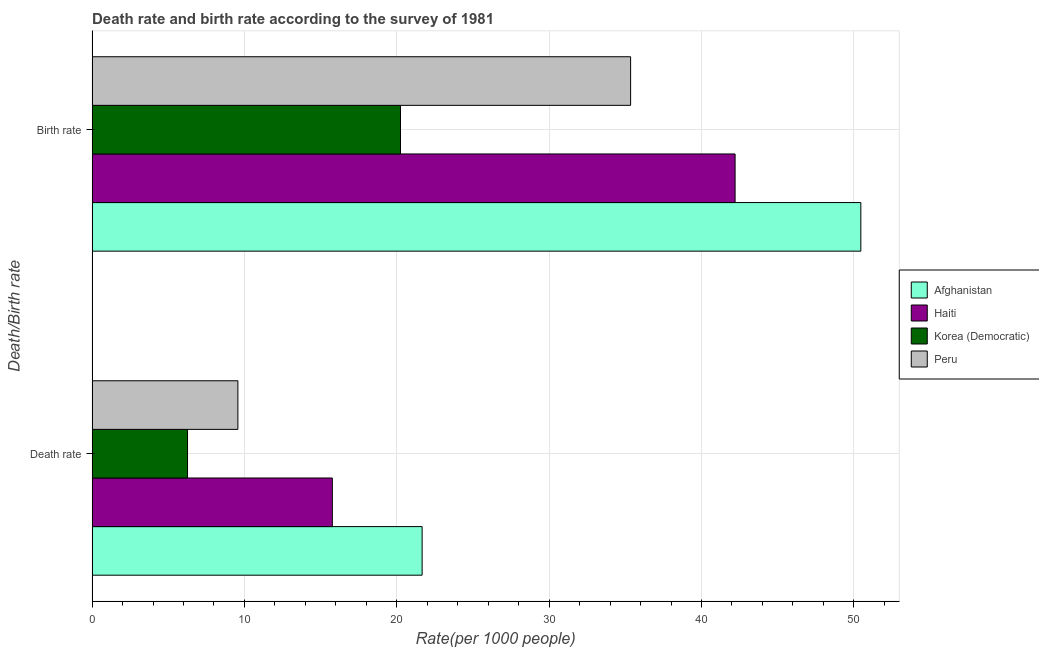How many different coloured bars are there?
Give a very brief answer. 4. Are the number of bars per tick equal to the number of legend labels?
Your response must be concise. Yes. How many bars are there on the 2nd tick from the bottom?
Make the answer very short. 4. What is the label of the 1st group of bars from the top?
Ensure brevity in your answer.  Birth rate. What is the death rate in Korea (Democratic)?
Keep it short and to the point. 6.26. Across all countries, what is the maximum birth rate?
Your answer should be compact. 50.46. Across all countries, what is the minimum death rate?
Give a very brief answer. 6.26. In which country was the birth rate maximum?
Ensure brevity in your answer.  Afghanistan. In which country was the birth rate minimum?
Your answer should be compact. Korea (Democratic). What is the total death rate in the graph?
Provide a succinct answer. 53.26. What is the difference between the death rate in Afghanistan and that in Peru?
Your answer should be compact. 12.09. What is the difference between the death rate in Afghanistan and the birth rate in Korea (Democratic)?
Provide a succinct answer. 1.42. What is the average birth rate per country?
Provide a succinct answer. 37.06. What is the difference between the birth rate and death rate in Haiti?
Offer a very short reply. 26.44. What is the ratio of the death rate in Afghanistan to that in Korea (Democratic)?
Provide a short and direct response. 3.46. In how many countries, is the birth rate greater than the average birth rate taken over all countries?
Make the answer very short. 2. What does the 3rd bar from the top in Death rate represents?
Your answer should be compact. Haiti. What does the 1st bar from the bottom in Birth rate represents?
Provide a short and direct response. Afghanistan. How many bars are there?
Your response must be concise. 8. Are all the bars in the graph horizontal?
Give a very brief answer. Yes. Does the graph contain grids?
Provide a succinct answer. Yes. Where does the legend appear in the graph?
Offer a very short reply. Center right. How many legend labels are there?
Make the answer very short. 4. How are the legend labels stacked?
Your response must be concise. Vertical. What is the title of the graph?
Make the answer very short. Death rate and birth rate according to the survey of 1981. What is the label or title of the X-axis?
Make the answer very short. Rate(per 1000 people). What is the label or title of the Y-axis?
Provide a short and direct response. Death/Birth rate. What is the Rate(per 1000 people) in Afghanistan in Death rate?
Provide a succinct answer. 21.66. What is the Rate(per 1000 people) of Haiti in Death rate?
Your answer should be very brief. 15.77. What is the Rate(per 1000 people) in Korea (Democratic) in Death rate?
Your answer should be compact. 6.26. What is the Rate(per 1000 people) of Peru in Death rate?
Keep it short and to the point. 9.57. What is the Rate(per 1000 people) of Afghanistan in Birth rate?
Provide a succinct answer. 50.46. What is the Rate(per 1000 people) of Haiti in Birth rate?
Your answer should be compact. 42.2. What is the Rate(per 1000 people) in Korea (Democratic) in Birth rate?
Your answer should be compact. 20.24. What is the Rate(per 1000 people) of Peru in Birth rate?
Ensure brevity in your answer.  35.35. Across all Death/Birth rate, what is the maximum Rate(per 1000 people) in Afghanistan?
Your answer should be very brief. 50.46. Across all Death/Birth rate, what is the maximum Rate(per 1000 people) in Haiti?
Keep it short and to the point. 42.2. Across all Death/Birth rate, what is the maximum Rate(per 1000 people) of Korea (Democratic)?
Provide a succinct answer. 20.24. Across all Death/Birth rate, what is the maximum Rate(per 1000 people) in Peru?
Your answer should be very brief. 35.35. Across all Death/Birth rate, what is the minimum Rate(per 1000 people) of Afghanistan?
Keep it short and to the point. 21.66. Across all Death/Birth rate, what is the minimum Rate(per 1000 people) of Haiti?
Ensure brevity in your answer.  15.77. Across all Death/Birth rate, what is the minimum Rate(per 1000 people) of Korea (Democratic)?
Provide a short and direct response. 6.26. Across all Death/Birth rate, what is the minimum Rate(per 1000 people) of Peru?
Ensure brevity in your answer.  9.57. What is the total Rate(per 1000 people) in Afghanistan in the graph?
Provide a succinct answer. 72.12. What is the total Rate(per 1000 people) in Haiti in the graph?
Ensure brevity in your answer.  57.97. What is the total Rate(per 1000 people) in Korea (Democratic) in the graph?
Offer a very short reply. 26.51. What is the total Rate(per 1000 people) in Peru in the graph?
Provide a succinct answer. 44.92. What is the difference between the Rate(per 1000 people) of Afghanistan in Death rate and that in Birth rate?
Ensure brevity in your answer.  -28.8. What is the difference between the Rate(per 1000 people) in Haiti in Death rate and that in Birth rate?
Your answer should be very brief. -26.44. What is the difference between the Rate(per 1000 people) in Korea (Democratic) in Death rate and that in Birth rate?
Your answer should be very brief. -13.98. What is the difference between the Rate(per 1000 people) in Peru in Death rate and that in Birth rate?
Give a very brief answer. -25.78. What is the difference between the Rate(per 1000 people) in Afghanistan in Death rate and the Rate(per 1000 people) in Haiti in Birth rate?
Make the answer very short. -20.54. What is the difference between the Rate(per 1000 people) of Afghanistan in Death rate and the Rate(per 1000 people) of Korea (Democratic) in Birth rate?
Your answer should be compact. 1.42. What is the difference between the Rate(per 1000 people) in Afghanistan in Death rate and the Rate(per 1000 people) in Peru in Birth rate?
Your answer should be compact. -13.69. What is the difference between the Rate(per 1000 people) of Haiti in Death rate and the Rate(per 1000 people) of Korea (Democratic) in Birth rate?
Offer a very short reply. -4.47. What is the difference between the Rate(per 1000 people) of Haiti in Death rate and the Rate(per 1000 people) of Peru in Birth rate?
Your answer should be very brief. -19.58. What is the difference between the Rate(per 1000 people) in Korea (Democratic) in Death rate and the Rate(per 1000 people) in Peru in Birth rate?
Ensure brevity in your answer.  -29.08. What is the average Rate(per 1000 people) in Afghanistan per Death/Birth rate?
Keep it short and to the point. 36.06. What is the average Rate(per 1000 people) in Haiti per Death/Birth rate?
Give a very brief answer. 28.99. What is the average Rate(per 1000 people) in Korea (Democratic) per Death/Birth rate?
Keep it short and to the point. 13.25. What is the average Rate(per 1000 people) in Peru per Death/Birth rate?
Keep it short and to the point. 22.46. What is the difference between the Rate(per 1000 people) in Afghanistan and Rate(per 1000 people) in Haiti in Death rate?
Provide a succinct answer. 5.89. What is the difference between the Rate(per 1000 people) of Afghanistan and Rate(per 1000 people) of Korea (Democratic) in Death rate?
Offer a very short reply. 15.4. What is the difference between the Rate(per 1000 people) in Afghanistan and Rate(per 1000 people) in Peru in Death rate?
Keep it short and to the point. 12.09. What is the difference between the Rate(per 1000 people) in Haiti and Rate(per 1000 people) in Korea (Democratic) in Death rate?
Your response must be concise. 9.51. What is the difference between the Rate(per 1000 people) in Haiti and Rate(per 1000 people) in Peru in Death rate?
Provide a short and direct response. 6.2. What is the difference between the Rate(per 1000 people) in Korea (Democratic) and Rate(per 1000 people) in Peru in Death rate?
Make the answer very short. -3.31. What is the difference between the Rate(per 1000 people) of Afghanistan and Rate(per 1000 people) of Haiti in Birth rate?
Offer a very short reply. 8.25. What is the difference between the Rate(per 1000 people) in Afghanistan and Rate(per 1000 people) in Korea (Democratic) in Birth rate?
Provide a short and direct response. 30.21. What is the difference between the Rate(per 1000 people) in Afghanistan and Rate(per 1000 people) in Peru in Birth rate?
Your answer should be compact. 15.11. What is the difference between the Rate(per 1000 people) of Haiti and Rate(per 1000 people) of Korea (Democratic) in Birth rate?
Your answer should be compact. 21.96. What is the difference between the Rate(per 1000 people) of Haiti and Rate(per 1000 people) of Peru in Birth rate?
Offer a terse response. 6.86. What is the difference between the Rate(per 1000 people) in Korea (Democratic) and Rate(per 1000 people) in Peru in Birth rate?
Provide a short and direct response. -15.1. What is the ratio of the Rate(per 1000 people) in Afghanistan in Death rate to that in Birth rate?
Ensure brevity in your answer.  0.43. What is the ratio of the Rate(per 1000 people) in Haiti in Death rate to that in Birth rate?
Your response must be concise. 0.37. What is the ratio of the Rate(per 1000 people) of Korea (Democratic) in Death rate to that in Birth rate?
Provide a succinct answer. 0.31. What is the ratio of the Rate(per 1000 people) in Peru in Death rate to that in Birth rate?
Your answer should be compact. 0.27. What is the difference between the highest and the second highest Rate(per 1000 people) in Afghanistan?
Ensure brevity in your answer.  28.8. What is the difference between the highest and the second highest Rate(per 1000 people) of Haiti?
Provide a succinct answer. 26.44. What is the difference between the highest and the second highest Rate(per 1000 people) of Korea (Democratic)?
Provide a short and direct response. 13.98. What is the difference between the highest and the second highest Rate(per 1000 people) of Peru?
Your answer should be very brief. 25.78. What is the difference between the highest and the lowest Rate(per 1000 people) of Afghanistan?
Make the answer very short. 28.8. What is the difference between the highest and the lowest Rate(per 1000 people) in Haiti?
Your answer should be very brief. 26.44. What is the difference between the highest and the lowest Rate(per 1000 people) in Korea (Democratic)?
Provide a succinct answer. 13.98. What is the difference between the highest and the lowest Rate(per 1000 people) of Peru?
Your answer should be very brief. 25.78. 